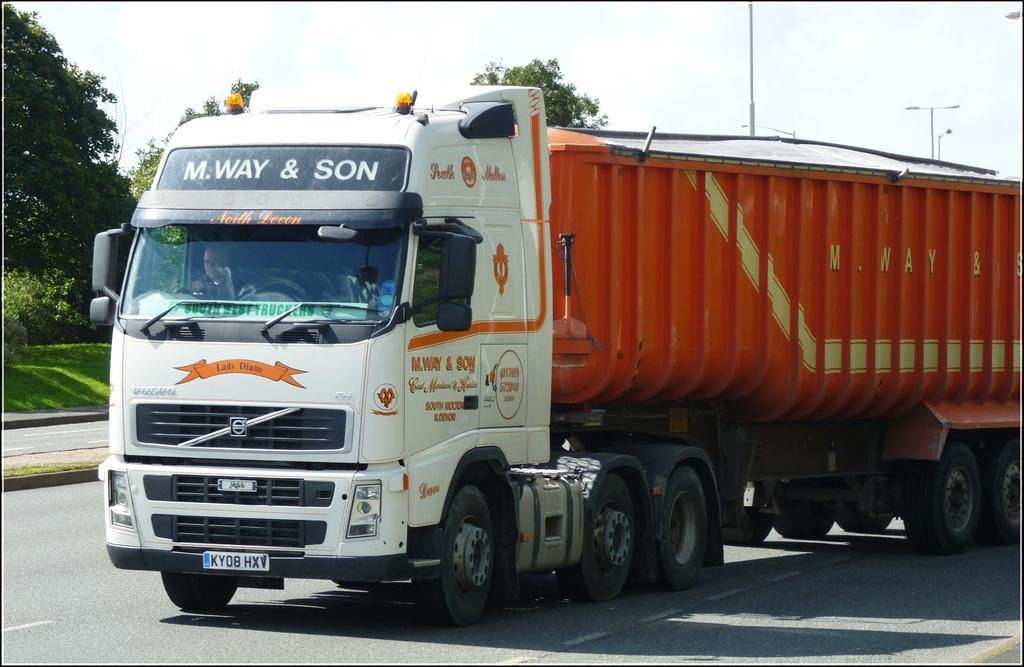What is the main subject of the image? The main subject of the image is a lorry. Where is the lorry located in the image? The lorry is on the road in the image. What is the color of the lorry? The lorry is white and orange in color. What can be seen in the background of the image? In the background of the image, there are trees, poles, and the sky. What is the condition of the sky in the image? The sky is visible with clouds in the background of the image. Can you see any muscles on the lorry in the image? There are no muscles present on the lorry in the image, as it is a vehicle and not a living being. Is there a crown visible on the lorry in the image? There is no crown present on the lorry in the image. 